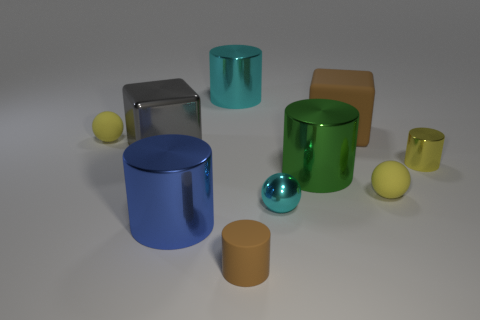Subtract all big cylinders. How many cylinders are left? 2 Subtract all green cylinders. How many cylinders are left? 4 Subtract all blocks. How many objects are left? 8 Subtract 1 cylinders. How many cylinders are left? 4 Subtract all brown cubes. Subtract all cyan spheres. How many cubes are left? 1 Subtract all yellow cylinders. How many purple spheres are left? 0 Subtract all large gray things. Subtract all big blue cylinders. How many objects are left? 8 Add 8 small brown cylinders. How many small brown cylinders are left? 9 Add 6 large gray blocks. How many large gray blocks exist? 7 Subtract 1 brown cylinders. How many objects are left? 9 